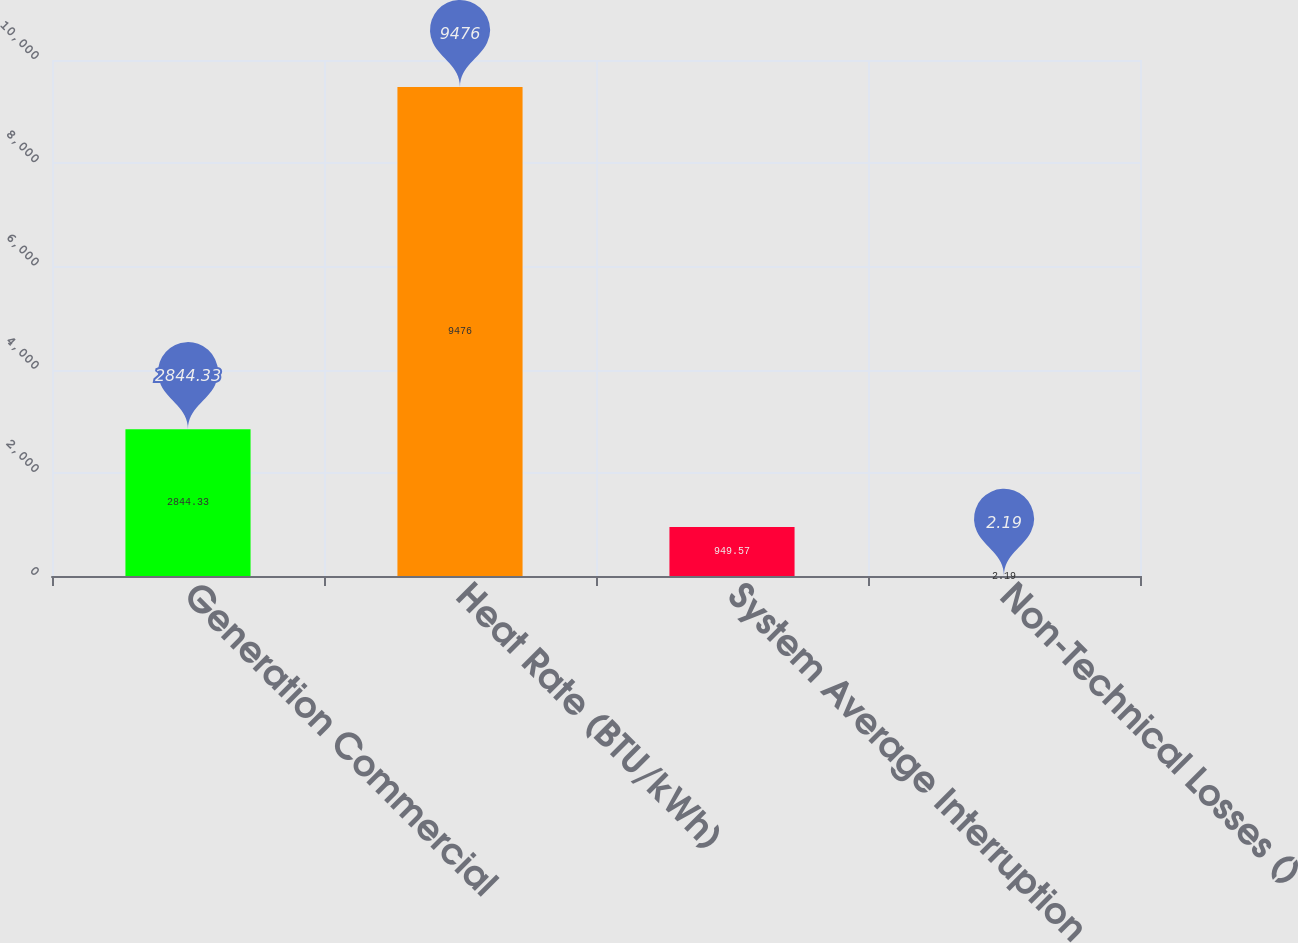Convert chart to OTSL. <chart><loc_0><loc_0><loc_500><loc_500><bar_chart><fcel>Generation Commercial<fcel>Heat Rate (BTU/kWh)<fcel>System Average Interruption<fcel>Non-Technical Losses ()<nl><fcel>2844.33<fcel>9476<fcel>949.57<fcel>2.19<nl></chart> 